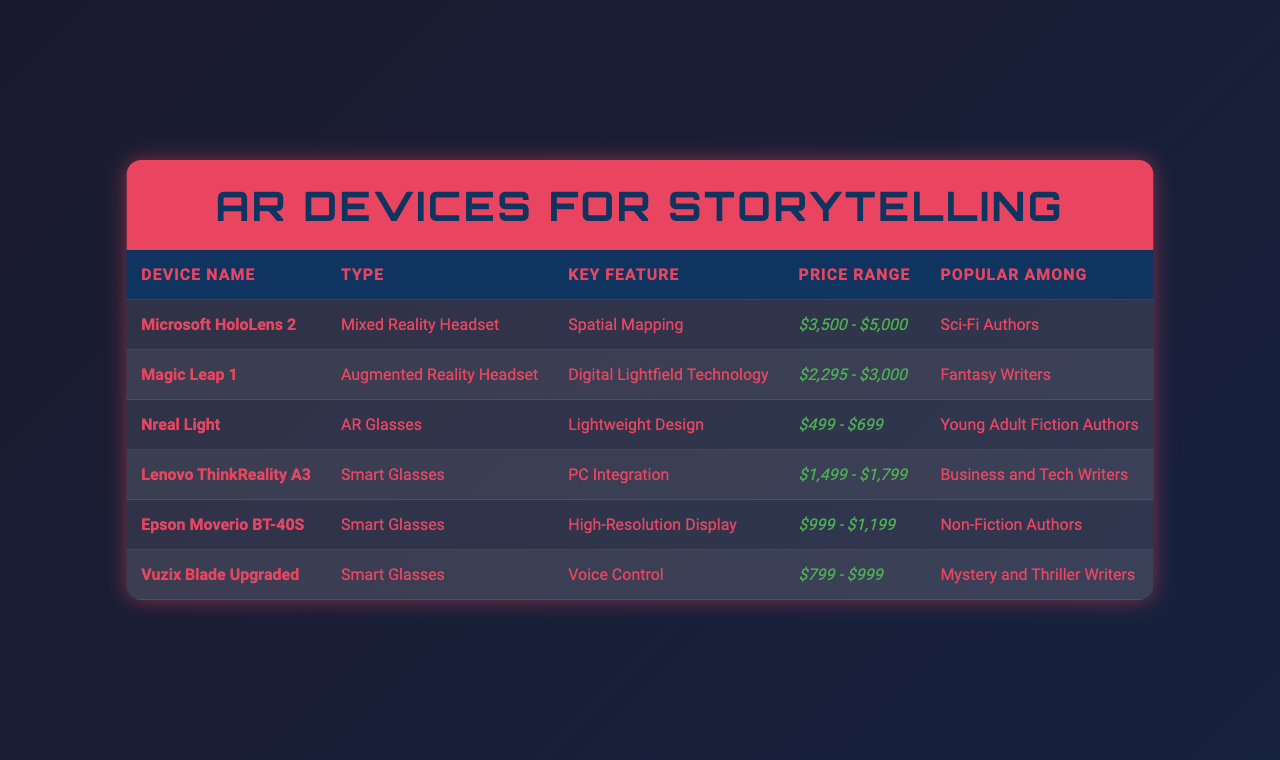What is the key feature of the Microsoft HoloLens 2? The table shows that the key feature of the Microsoft HoloLens 2 is "Spatial Mapping."
Answer: Spatial Mapping Which device is popular among Sci-Fi authors? From the table, it is indicated that the Microsoft HoloLens 2 is popular among Sci-Fi authors.
Answer: Microsoft HoloLens 2 How much do Nreal Light glasses cost at minimum? The minimum price range for Nreal Light is $499 as listed in the table.
Answer: $499 Is the Magic Leap 1 more expensive than the Lenovo ThinkReality A3? The price range for Magic Leap 1 is $2,295 - $3,000 and for Lenovo ThinkReality A3 is $1,499 - $1,799. Since the lowest price of Magic Leap 1 is higher than the highest price of Lenovo ThinkReality A3, the statement is true.
Answer: Yes What type of AR device is the Vuzix Blade Upgraded? The table specifies that the Vuzix Blade Upgraded is categorized as "Smart Glasses."
Answer: Smart Glasses Which AR device has a lightweight design? According to the table, the Nreal Light is noted for its "Lightweight Design."
Answer: Nreal Light What is the average price range of all the devices listed? The price ranges of all devices are $3,500 - $5,000, $2,295 - $3,000, $499 - $699, $1,499 - $1,799, $999 - $1,199, and $799 - $999. To find the averages, we can take the midpoint of each range. First, sum the midpoints: (4250 + 2647.5 + 599 + 1399 + 1099 + 899) = 11544. Then, divide by the number of devices (6): 11544 / 6 = 1924. So, the average price range is approximately $1924.
Answer: $1924 Which device is the cheapest among the listed options? From the table, the Nreal Light, with a price range of $499 - $699, is the cheapest.
Answer: Nreal Light Are the Epson Moverio BT-40S glasses more expensive than the Vuzix Blade Upgraded? The price range for Epson Moverio BT-40S is $999 - $1,199 while Vuzix Blade Upgraded ranges from $799 - $999. Since the highest price of Epson Moverio BT-40S is greater than the highest price of Vuzix Blade Upgraded, the answer is yes.
Answer: Yes Which types of authors prefer the Lenovo ThinkReality A3? The table indicates that the Lenovo ThinkReality A3 is popular among Business and Tech Writers.
Answer: Business and Tech Writers 